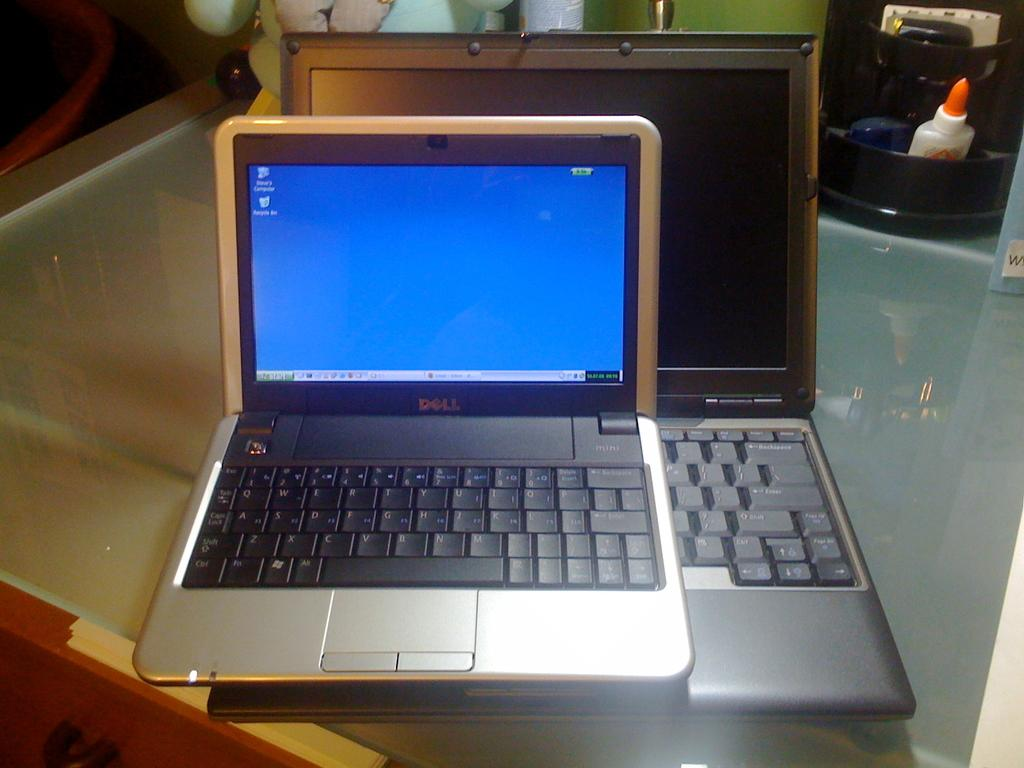<image>
Relay a brief, clear account of the picture shown. The laptop has the words Dell on the front 